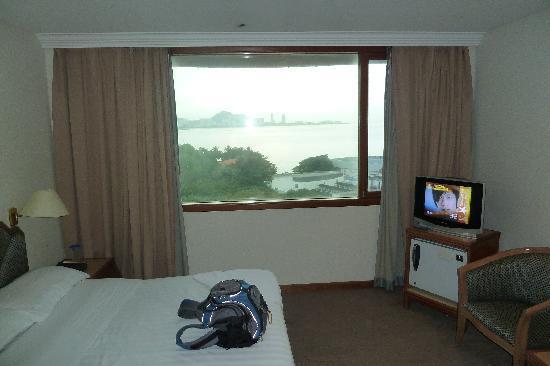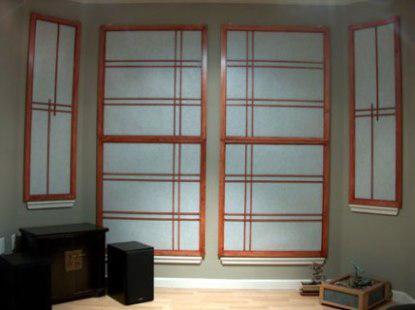The first image is the image on the left, the second image is the image on the right. For the images displayed, is the sentence "There are open vertical blinds in the left image." factually correct? Answer yes or no. No. The first image is the image on the left, the second image is the image on the right. Assess this claim about the two images: "An image shows a motel-type room with beige drapes on a big window, and a TV on a wooden stand.". Correct or not? Answer yes or no. Yes. 